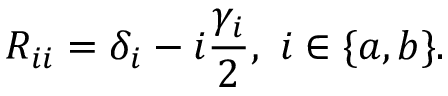Convert formula to latex. <formula><loc_0><loc_0><loc_500><loc_500>R _ { i i } = \delta _ { i } - i \frac { \gamma _ { i } } { 2 } , \, i \in \{ a , b \} .</formula> 